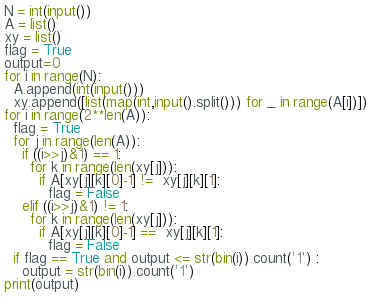Convert code to text. <code><loc_0><loc_0><loc_500><loc_500><_Python_>N = int(input())
A = list()
xy = list()
flag = True
output=0
for i in range(N):
  A.append(int(input()))
  xy.append([list(map(int,input().split())) for _ in range(A[i])])
for i in range(2**len(A)):
  flag = True
  for j in range(len(A)):
    if ((i>>j)&1) == 1:
      for k in range(len(xy[j])):
        if A[xy[j][k][0]-1] !=  xy[j][k][1]:
          flag = False
    elif ((i>>j)&1) != 1:
      for k in range(len(xy[j])):
        if A[xy[j][k][0]-1] ==  xy[j][k][1]:
          flag = False
  if flag == True and output <= str(bin(i)).count('1') :
    output = str(bin(i)).count('1')
print(output)
        </code> 